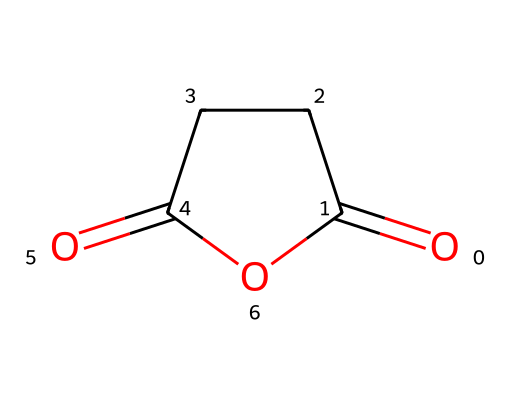What is the chemical name of this compound? The SMILES representation indicates that the molecule consists of carbon, oxygen, and cyclic structure; thus, it is identified as succinic anhydride.
Answer: succinic anhydride How many carbon atoms are present in the structure? By inspecting the structure represented in the SMILES, there are four carbon atoms reflected in the cyclic nature of the molecule.
Answer: 4 What is the total number of oxygen atoms in this compound? From the SMILES representation, we observe that there are two carbonyl (C=O) groups and one cyclic ether oxygen atom, making a total of three oxygen atoms.
Answer: 3 What type of acid anhydride is this compound? Given that it is formed from succinic acid, it is classified as a dicarboxylic acid anhydride.
Answer: dicarboxylic How many bonds are between the carbon atoms? The connectivity in the cyclic structure shows that there are three single bonds and one double bond between the carbon atoms in the anhydride.
Answer: 4 What functional groups can be identified in this molecule? The structure exhibits both anhydride and carbonyl functional groups due to the characteristic cyclic arrangement and presence of carbonyls.
Answer: anhydride and carbonyl 